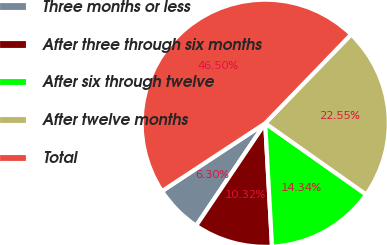<chart> <loc_0><loc_0><loc_500><loc_500><pie_chart><fcel>Three months or less<fcel>After three through six months<fcel>After six through twelve<fcel>After twelve months<fcel>Total<nl><fcel>6.3%<fcel>10.32%<fcel>14.34%<fcel>22.55%<fcel>46.5%<nl></chart> 